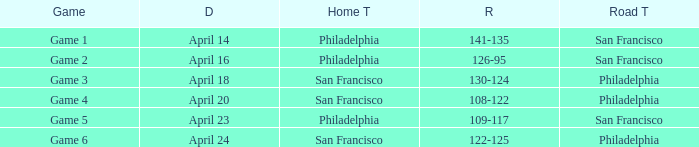Which game had a result of 126-95? Game 2. 